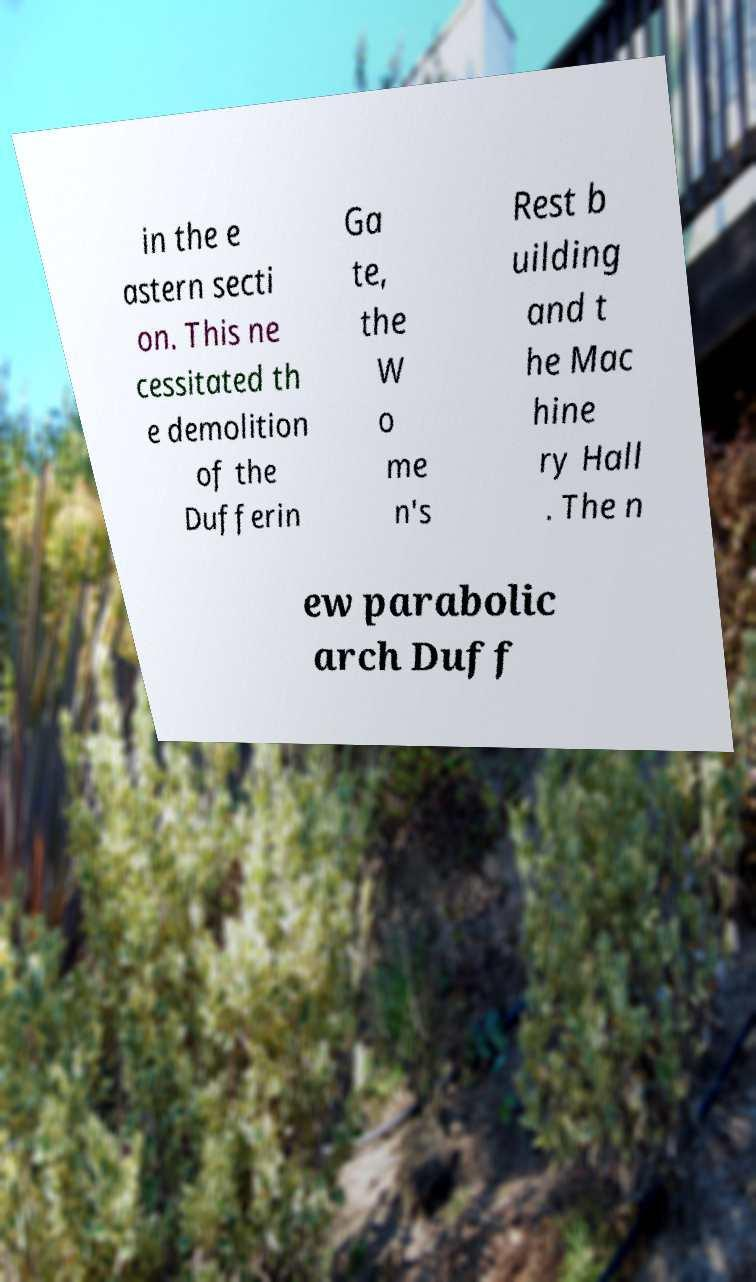What messages or text are displayed in this image? I need them in a readable, typed format. in the e astern secti on. This ne cessitated th e demolition of the Dufferin Ga te, the W o me n's Rest b uilding and t he Mac hine ry Hall . The n ew parabolic arch Duff 